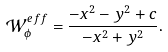<formula> <loc_0><loc_0><loc_500><loc_500>\mathcal { W } _ { \phi } ^ { e f f } = \frac { - x ^ { 2 } - y ^ { 2 } + c } { - x ^ { 2 } + y ^ { 2 } } .</formula> 